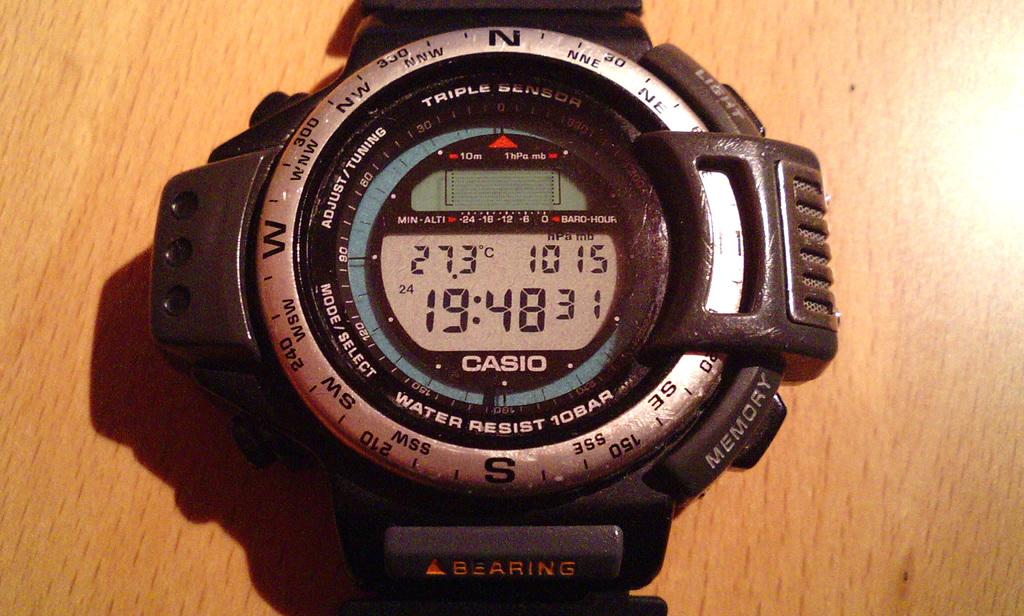What brand is this watch?
Provide a succinct answer. Casio. 